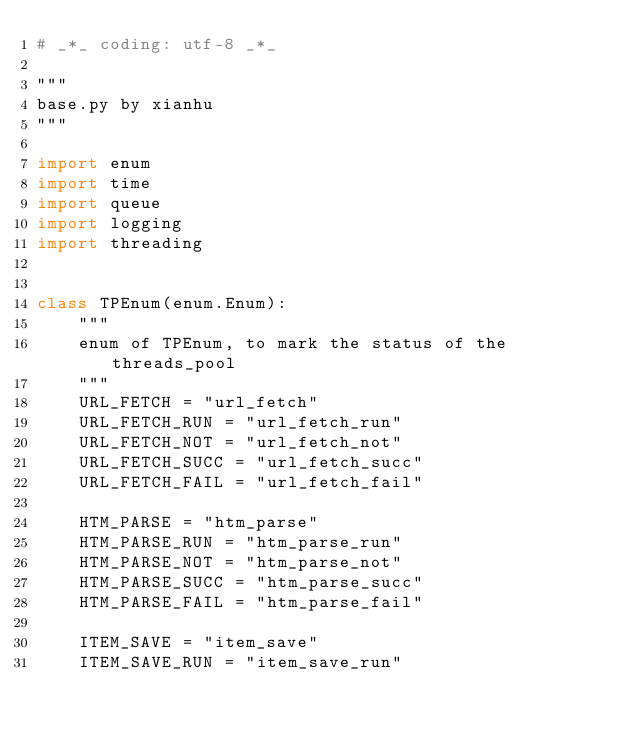Convert code to text. <code><loc_0><loc_0><loc_500><loc_500><_Python_># _*_ coding: utf-8 _*_

"""
base.py by xianhu
"""

import enum
import time
import queue
import logging
import threading


class TPEnum(enum.Enum):
    """
    enum of TPEnum, to mark the status of the threads_pool
    """
    URL_FETCH = "url_fetch"
    URL_FETCH_RUN = "url_fetch_run"
    URL_FETCH_NOT = "url_fetch_not"
    URL_FETCH_SUCC = "url_fetch_succ"
    URL_FETCH_FAIL = "url_fetch_fail"

    HTM_PARSE = "htm_parse"
    HTM_PARSE_RUN = "htm_parse_run"
    HTM_PARSE_NOT = "htm_parse_not"
    HTM_PARSE_SUCC = "htm_parse_succ"
    HTM_PARSE_FAIL = "htm_parse_fail"

    ITEM_SAVE = "item_save"
    ITEM_SAVE_RUN = "item_save_run"</code> 